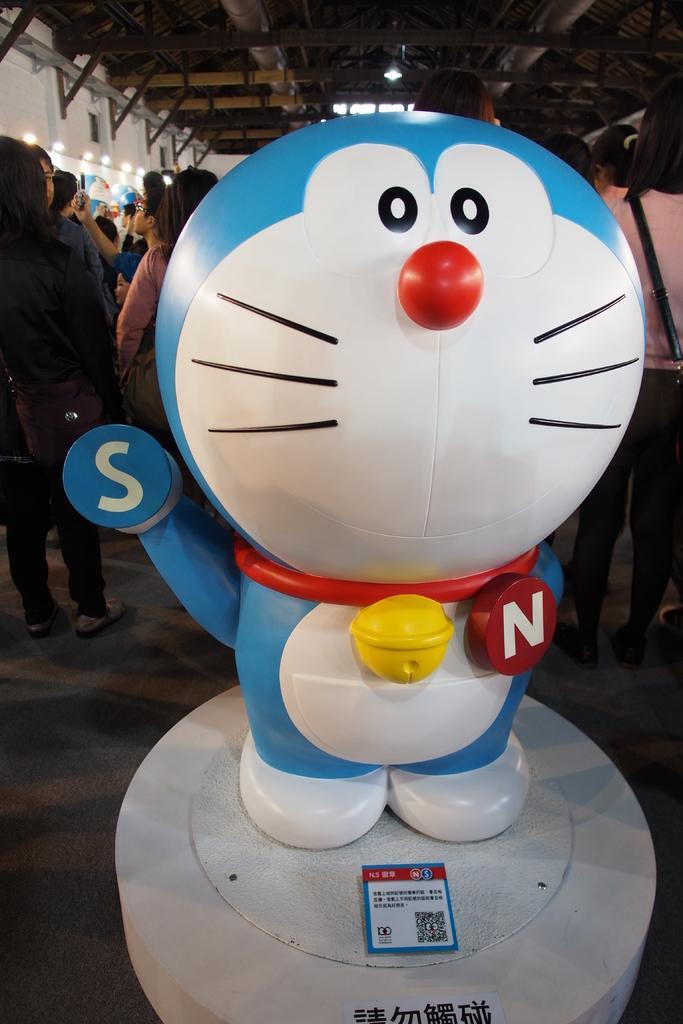Please provide a concise description of this image. In the picture we can see a doll on the white color and substance behind it, we can see a group of people standing in the hall and to the ceiling we can see a light and to the wall also we can see some lights. 